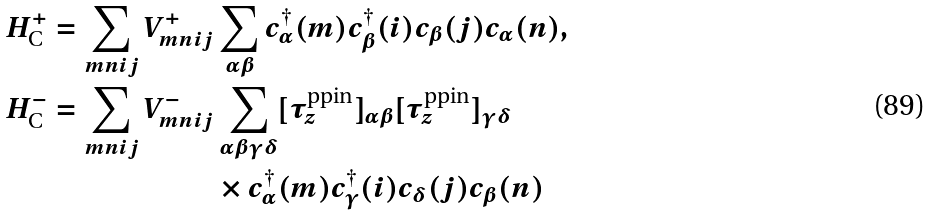Convert formula to latex. <formula><loc_0><loc_0><loc_500><loc_500>H _ { \text {C} } ^ { + } = \sum _ { m n i j } { V } _ { m n i j } ^ { + } & \sum _ { \alpha \beta } c _ { \alpha } ^ { \dagger } ( m ) c _ { \beta } ^ { \dagger } ( i ) c _ { \beta } ( j ) c _ { \alpha } ( n ) , \\ H _ { \text {C} } ^ { - } = \sum _ { m n i j } { V } _ { m n i j } ^ { - } & \sum _ { \alpha \beta \gamma \delta } [ \tau _ { z } ^ { \text {ppin} } ] _ { \alpha \beta } [ \tau _ { z } ^ { \text {ppin} } ] _ { \gamma \delta } \\ & \times c _ { \alpha } ^ { \dagger } ( m ) c _ { \gamma } ^ { \dagger } ( i ) c _ { \delta } ( j ) c _ { \beta } ( n )</formula> 